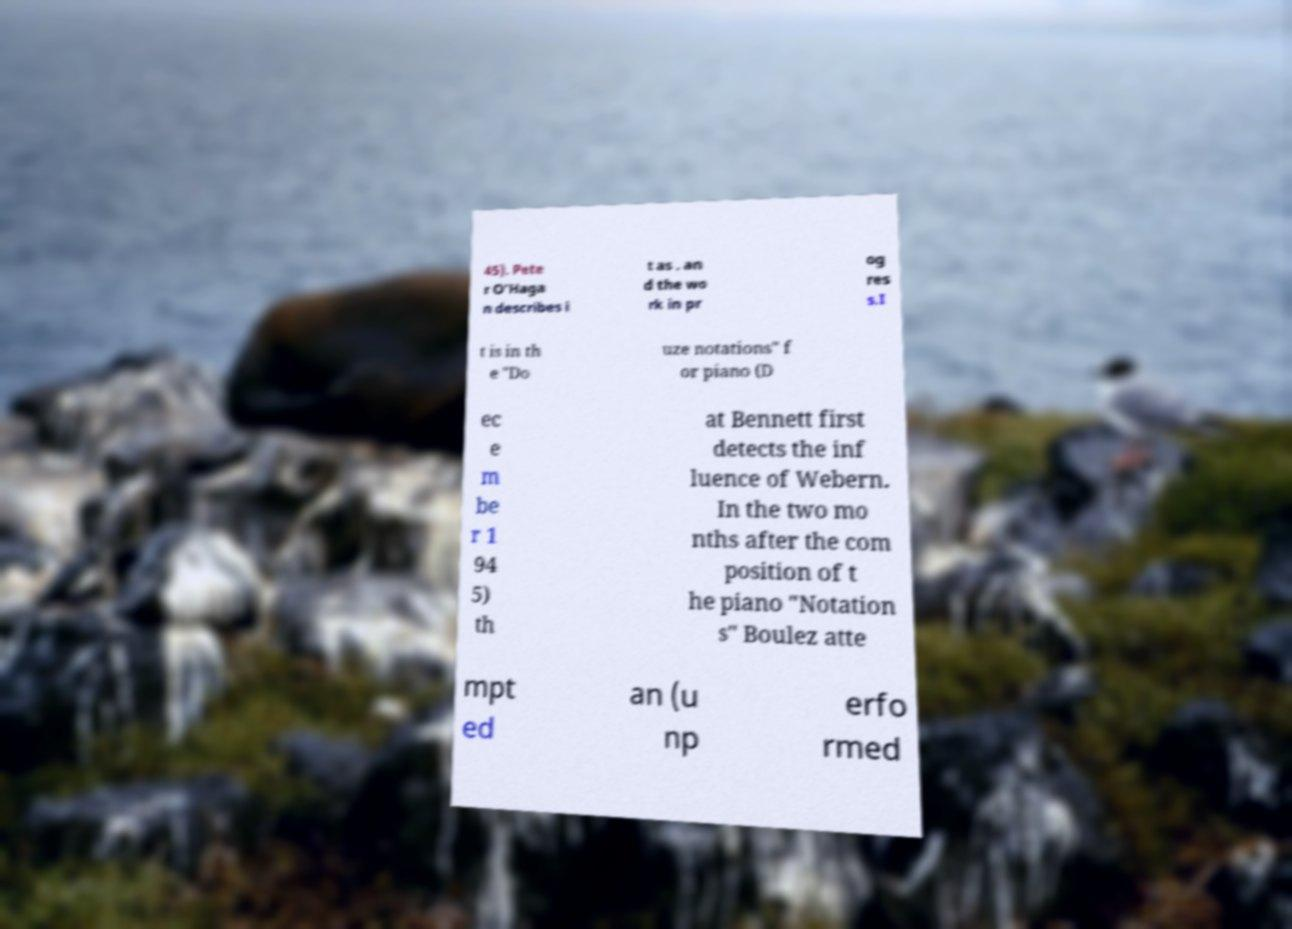Can you read and provide the text displayed in the image?This photo seems to have some interesting text. Can you extract and type it out for me? 45). Pete r O'Haga n describes i t as . an d the wo rk in pr og res s.I t is in th e "Do uze notations" f or piano (D ec e m be r 1 94 5) th at Bennett first detects the inf luence of Webern. In the two mo nths after the com position of t he piano "Notation s" Boulez atte mpt ed an (u np erfo rmed 